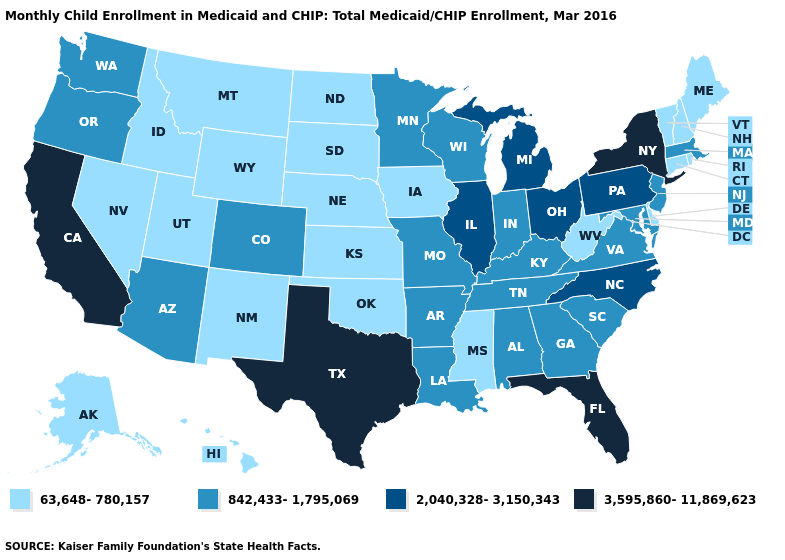What is the highest value in the MidWest ?
Short answer required. 2,040,328-3,150,343. Does Connecticut have a lower value than Pennsylvania?
Concise answer only. Yes. Name the states that have a value in the range 2,040,328-3,150,343?
Short answer required. Illinois, Michigan, North Carolina, Ohio, Pennsylvania. Does Oklahoma have the lowest value in the South?
Answer briefly. Yes. Does Illinois have a lower value than West Virginia?
Quick response, please. No. Does Florida have the same value as Kentucky?
Keep it brief. No. What is the lowest value in the USA?
Concise answer only. 63,648-780,157. Which states hav the highest value in the West?
Be succinct. California. Does Alabama have a lower value than Nevada?
Keep it brief. No. What is the value of Missouri?
Quick response, please. 842,433-1,795,069. Name the states that have a value in the range 3,595,860-11,869,623?
Answer briefly. California, Florida, New York, Texas. Name the states that have a value in the range 63,648-780,157?
Write a very short answer. Alaska, Connecticut, Delaware, Hawaii, Idaho, Iowa, Kansas, Maine, Mississippi, Montana, Nebraska, Nevada, New Hampshire, New Mexico, North Dakota, Oklahoma, Rhode Island, South Dakota, Utah, Vermont, West Virginia, Wyoming. What is the value of Maine?
Quick response, please. 63,648-780,157. 